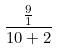<formula> <loc_0><loc_0><loc_500><loc_500>\frac { \frac { 9 } { 1 } } { 1 0 + 2 }</formula> 